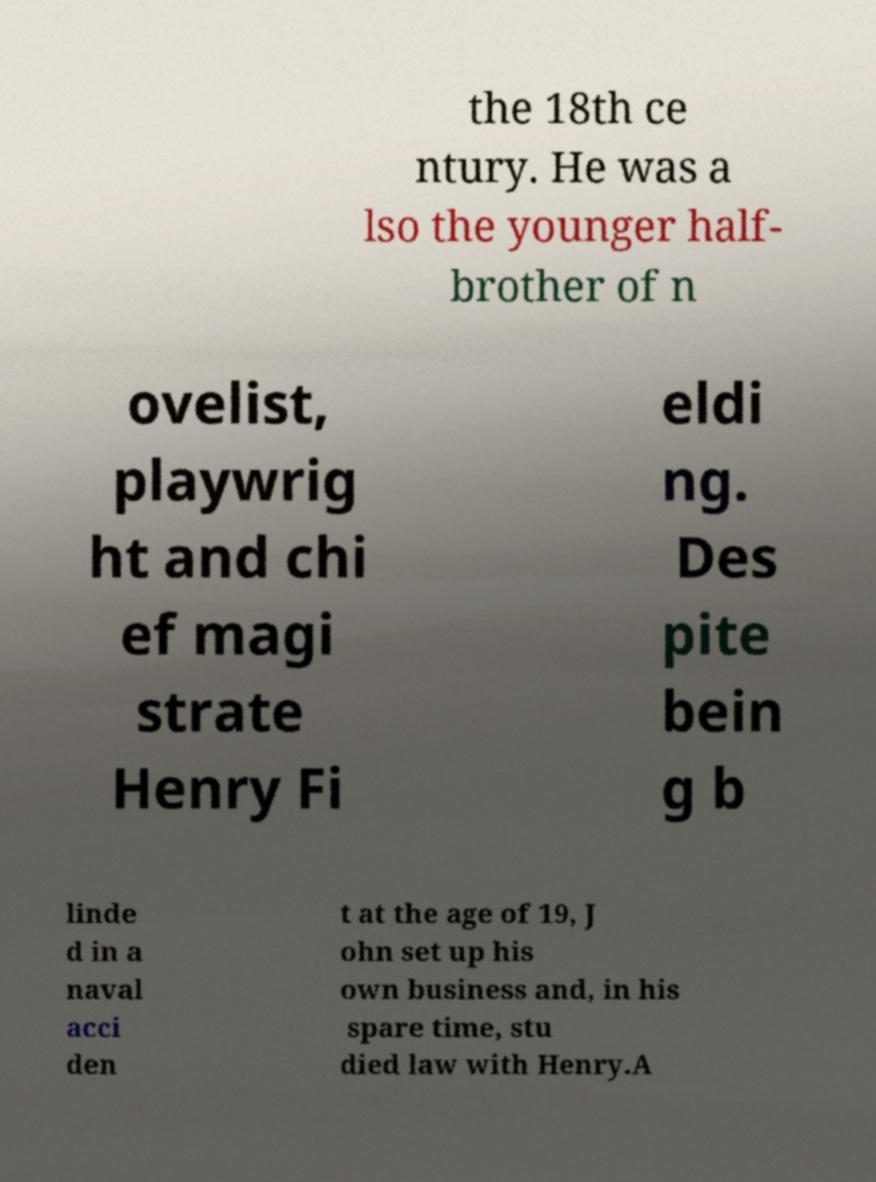Could you assist in decoding the text presented in this image and type it out clearly? the 18th ce ntury. He was a lso the younger half- brother of n ovelist, playwrig ht and chi ef magi strate Henry Fi eldi ng. Des pite bein g b linde d in a naval acci den t at the age of 19, J ohn set up his own business and, in his spare time, stu died law with Henry.A 